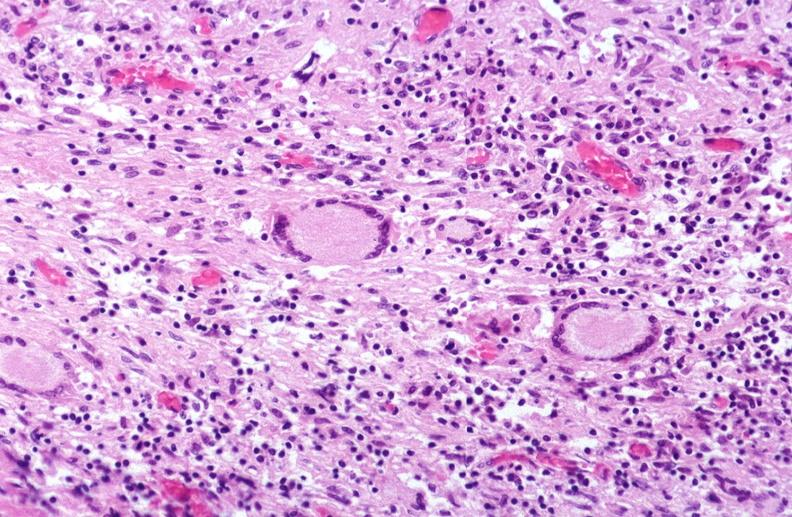s maxillary sinus present?
Answer the question using a single word or phrase. No 